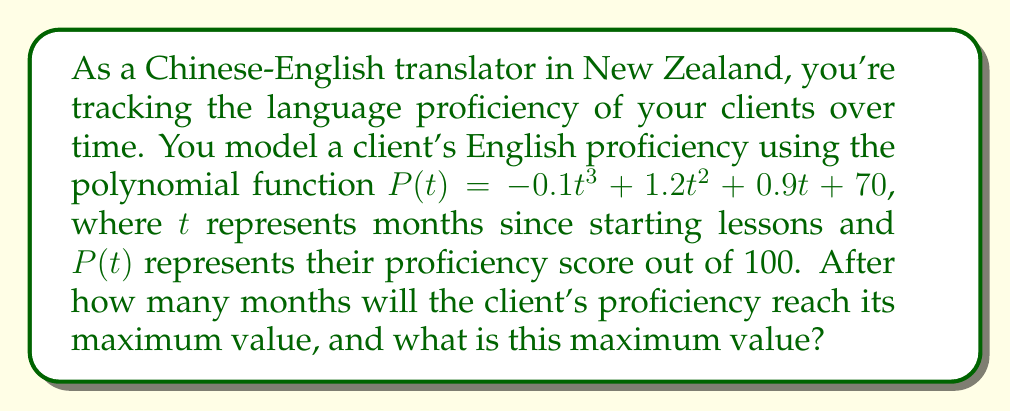Could you help me with this problem? To find the maximum value of the polynomial function, we need to follow these steps:

1) First, we need to find the derivative of $P(t)$:
   $P'(t) = -0.3t^2 + 2.4t + 0.9$

2) To find the critical points, set $P'(t) = 0$:
   $-0.3t^2 + 2.4t + 0.9 = 0$

3) This is a quadratic equation. We can solve it using the quadratic formula:
   $t = \frac{-b \pm \sqrt{b^2 - 4ac}}{2a}$

   Where $a = -0.3$, $b = 2.4$, and $c = 0.9$

4) Plugging in these values:
   $t = \frac{-2.4 \pm \sqrt{2.4^2 - 4(-0.3)(0.9)}}{2(-0.3)}$
   $= \frac{-2.4 \pm \sqrt{5.76 + 1.08}}{-0.6}$
   $= \frac{-2.4 \pm \sqrt{6.84}}{-0.6}$
   $= \frac{-2.4 \pm 2.615}{-0.6}$

5) This gives us two solutions:
   $t_1 = \frac{-2.4 + 2.615}{-0.6} = -0.358$
   $t_2 = \frac{-2.4 - 2.615}{-0.6} = 8.358$

6) Since time can't be negative in this context, we discard the negative solution. The maximum occurs at $t \approx 8.358$ months.

7) To find the maximum value, we plug this t-value back into the original function:
   $P(8.358) = -0.1(8.358)^3 + 1.2(8.358)^2 + 0.9(8.358) + 70$
              $\approx 84.175$

Therefore, the client's proficiency will reach its maximum value after approximately 8.36 months, and this maximum value is approximately 84.18.
Answer: 8.36 months; 84.18 